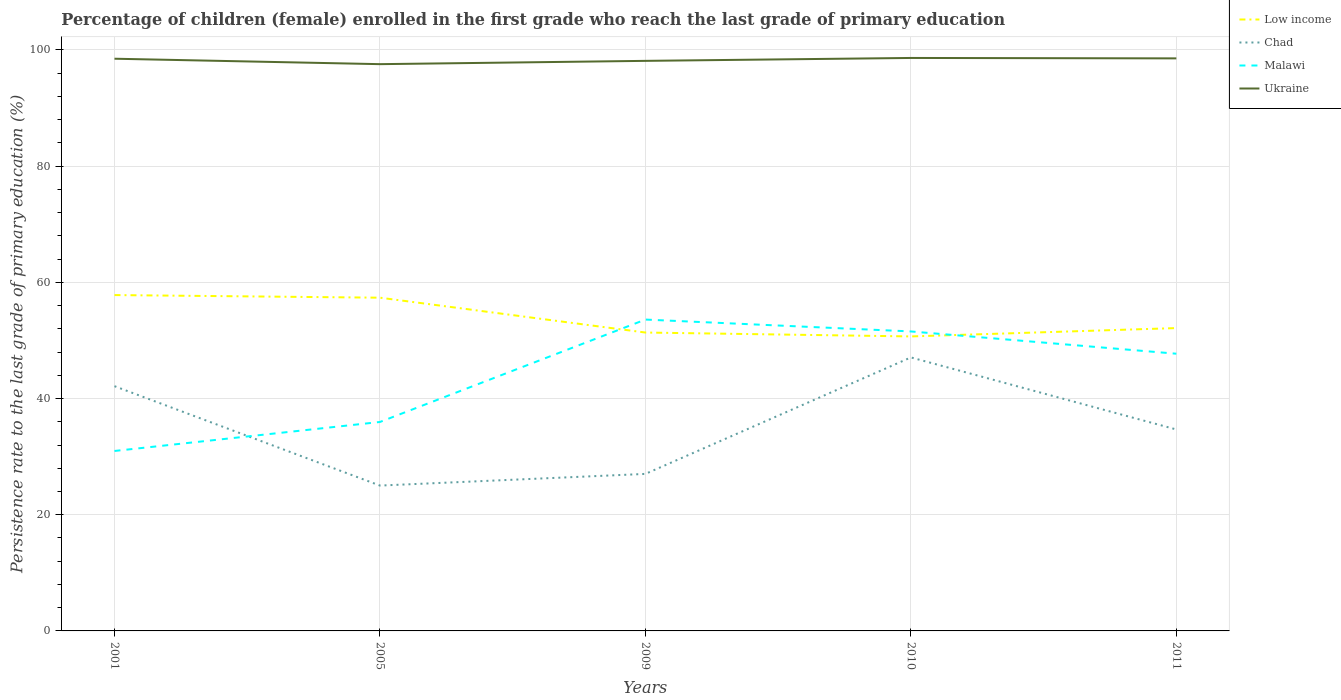Is the number of lines equal to the number of legend labels?
Ensure brevity in your answer.  Yes. Across all years, what is the maximum persistence rate of children in Ukraine?
Provide a short and direct response. 97.56. In which year was the persistence rate of children in Chad maximum?
Provide a short and direct response. 2005. What is the total persistence rate of children in Ukraine in the graph?
Offer a very short reply. -0.43. What is the difference between the highest and the second highest persistence rate of children in Ukraine?
Provide a succinct answer. 1.07. Is the persistence rate of children in Low income strictly greater than the persistence rate of children in Ukraine over the years?
Make the answer very short. Yes. How many lines are there?
Your response must be concise. 4. What is the difference between two consecutive major ticks on the Y-axis?
Provide a short and direct response. 20. Are the values on the major ticks of Y-axis written in scientific E-notation?
Your response must be concise. No. Does the graph contain any zero values?
Make the answer very short. No. Does the graph contain grids?
Your response must be concise. Yes. Where does the legend appear in the graph?
Your response must be concise. Top right. How many legend labels are there?
Offer a very short reply. 4. What is the title of the graph?
Your answer should be compact. Percentage of children (female) enrolled in the first grade who reach the last grade of primary education. What is the label or title of the Y-axis?
Your response must be concise. Persistence rate to the last grade of primary education (%). What is the Persistence rate to the last grade of primary education (%) in Low income in 2001?
Keep it short and to the point. 57.81. What is the Persistence rate to the last grade of primary education (%) in Chad in 2001?
Offer a terse response. 42.13. What is the Persistence rate to the last grade of primary education (%) in Malawi in 2001?
Your answer should be compact. 30.97. What is the Persistence rate to the last grade of primary education (%) in Ukraine in 2001?
Give a very brief answer. 98.49. What is the Persistence rate to the last grade of primary education (%) of Low income in 2005?
Offer a terse response. 57.36. What is the Persistence rate to the last grade of primary education (%) in Chad in 2005?
Provide a succinct answer. 25.02. What is the Persistence rate to the last grade of primary education (%) of Malawi in 2005?
Provide a succinct answer. 35.97. What is the Persistence rate to the last grade of primary education (%) of Ukraine in 2005?
Provide a short and direct response. 97.56. What is the Persistence rate to the last grade of primary education (%) in Low income in 2009?
Keep it short and to the point. 51.36. What is the Persistence rate to the last grade of primary education (%) in Chad in 2009?
Offer a very short reply. 27.03. What is the Persistence rate to the last grade of primary education (%) of Malawi in 2009?
Offer a terse response. 53.59. What is the Persistence rate to the last grade of primary education (%) in Ukraine in 2009?
Provide a succinct answer. 98.13. What is the Persistence rate to the last grade of primary education (%) in Low income in 2010?
Ensure brevity in your answer.  50.69. What is the Persistence rate to the last grade of primary education (%) of Chad in 2010?
Your response must be concise. 47.08. What is the Persistence rate to the last grade of primary education (%) of Malawi in 2010?
Offer a very short reply. 51.55. What is the Persistence rate to the last grade of primary education (%) of Ukraine in 2010?
Provide a short and direct response. 98.63. What is the Persistence rate to the last grade of primary education (%) in Low income in 2011?
Provide a short and direct response. 52.13. What is the Persistence rate to the last grade of primary education (%) of Chad in 2011?
Offer a very short reply. 34.68. What is the Persistence rate to the last grade of primary education (%) of Malawi in 2011?
Your answer should be compact. 47.72. What is the Persistence rate to the last grade of primary education (%) in Ukraine in 2011?
Your answer should be compact. 98.55. Across all years, what is the maximum Persistence rate to the last grade of primary education (%) in Low income?
Your response must be concise. 57.81. Across all years, what is the maximum Persistence rate to the last grade of primary education (%) in Chad?
Keep it short and to the point. 47.08. Across all years, what is the maximum Persistence rate to the last grade of primary education (%) of Malawi?
Offer a terse response. 53.59. Across all years, what is the maximum Persistence rate to the last grade of primary education (%) of Ukraine?
Make the answer very short. 98.63. Across all years, what is the minimum Persistence rate to the last grade of primary education (%) in Low income?
Your answer should be compact. 50.69. Across all years, what is the minimum Persistence rate to the last grade of primary education (%) of Chad?
Provide a succinct answer. 25.02. Across all years, what is the minimum Persistence rate to the last grade of primary education (%) of Malawi?
Provide a succinct answer. 30.97. Across all years, what is the minimum Persistence rate to the last grade of primary education (%) in Ukraine?
Provide a short and direct response. 97.56. What is the total Persistence rate to the last grade of primary education (%) in Low income in the graph?
Your response must be concise. 269.35. What is the total Persistence rate to the last grade of primary education (%) of Chad in the graph?
Your response must be concise. 175.93. What is the total Persistence rate to the last grade of primary education (%) in Malawi in the graph?
Provide a succinct answer. 219.8. What is the total Persistence rate to the last grade of primary education (%) of Ukraine in the graph?
Offer a very short reply. 491.36. What is the difference between the Persistence rate to the last grade of primary education (%) of Low income in 2001 and that in 2005?
Ensure brevity in your answer.  0.45. What is the difference between the Persistence rate to the last grade of primary education (%) of Chad in 2001 and that in 2005?
Ensure brevity in your answer.  17.11. What is the difference between the Persistence rate to the last grade of primary education (%) of Malawi in 2001 and that in 2005?
Offer a very short reply. -4.99. What is the difference between the Persistence rate to the last grade of primary education (%) of Ukraine in 2001 and that in 2005?
Offer a very short reply. 0.94. What is the difference between the Persistence rate to the last grade of primary education (%) of Low income in 2001 and that in 2009?
Provide a succinct answer. 6.45. What is the difference between the Persistence rate to the last grade of primary education (%) in Chad in 2001 and that in 2009?
Provide a short and direct response. 15.1. What is the difference between the Persistence rate to the last grade of primary education (%) of Malawi in 2001 and that in 2009?
Your answer should be very brief. -22.62. What is the difference between the Persistence rate to the last grade of primary education (%) of Ukraine in 2001 and that in 2009?
Provide a short and direct response. 0.37. What is the difference between the Persistence rate to the last grade of primary education (%) of Low income in 2001 and that in 2010?
Provide a short and direct response. 7.12. What is the difference between the Persistence rate to the last grade of primary education (%) of Chad in 2001 and that in 2010?
Your answer should be compact. -4.95. What is the difference between the Persistence rate to the last grade of primary education (%) in Malawi in 2001 and that in 2010?
Keep it short and to the point. -20.58. What is the difference between the Persistence rate to the last grade of primary education (%) of Ukraine in 2001 and that in 2010?
Provide a succinct answer. -0.13. What is the difference between the Persistence rate to the last grade of primary education (%) of Low income in 2001 and that in 2011?
Your answer should be compact. 5.68. What is the difference between the Persistence rate to the last grade of primary education (%) of Chad in 2001 and that in 2011?
Offer a very short reply. 7.45. What is the difference between the Persistence rate to the last grade of primary education (%) in Malawi in 2001 and that in 2011?
Your response must be concise. -16.74. What is the difference between the Persistence rate to the last grade of primary education (%) in Ukraine in 2001 and that in 2011?
Keep it short and to the point. -0.06. What is the difference between the Persistence rate to the last grade of primary education (%) in Low income in 2005 and that in 2009?
Provide a succinct answer. 6. What is the difference between the Persistence rate to the last grade of primary education (%) in Chad in 2005 and that in 2009?
Make the answer very short. -2.01. What is the difference between the Persistence rate to the last grade of primary education (%) in Malawi in 2005 and that in 2009?
Provide a short and direct response. -17.63. What is the difference between the Persistence rate to the last grade of primary education (%) in Ukraine in 2005 and that in 2009?
Your response must be concise. -0.57. What is the difference between the Persistence rate to the last grade of primary education (%) in Low income in 2005 and that in 2010?
Offer a very short reply. 6.67. What is the difference between the Persistence rate to the last grade of primary education (%) in Chad in 2005 and that in 2010?
Offer a terse response. -22.06. What is the difference between the Persistence rate to the last grade of primary education (%) in Malawi in 2005 and that in 2010?
Make the answer very short. -15.58. What is the difference between the Persistence rate to the last grade of primary education (%) of Ukraine in 2005 and that in 2010?
Your answer should be very brief. -1.07. What is the difference between the Persistence rate to the last grade of primary education (%) in Low income in 2005 and that in 2011?
Your answer should be compact. 5.23. What is the difference between the Persistence rate to the last grade of primary education (%) of Chad in 2005 and that in 2011?
Provide a short and direct response. -9.66. What is the difference between the Persistence rate to the last grade of primary education (%) in Malawi in 2005 and that in 2011?
Your response must be concise. -11.75. What is the difference between the Persistence rate to the last grade of primary education (%) in Ukraine in 2005 and that in 2011?
Give a very brief answer. -0.99. What is the difference between the Persistence rate to the last grade of primary education (%) of Low income in 2009 and that in 2010?
Make the answer very short. 0.67. What is the difference between the Persistence rate to the last grade of primary education (%) in Chad in 2009 and that in 2010?
Your response must be concise. -20.05. What is the difference between the Persistence rate to the last grade of primary education (%) in Malawi in 2009 and that in 2010?
Provide a short and direct response. 2.04. What is the difference between the Persistence rate to the last grade of primary education (%) of Ukraine in 2009 and that in 2010?
Offer a terse response. -0.5. What is the difference between the Persistence rate to the last grade of primary education (%) of Low income in 2009 and that in 2011?
Provide a short and direct response. -0.77. What is the difference between the Persistence rate to the last grade of primary education (%) in Chad in 2009 and that in 2011?
Your answer should be compact. -7.65. What is the difference between the Persistence rate to the last grade of primary education (%) in Malawi in 2009 and that in 2011?
Give a very brief answer. 5.88. What is the difference between the Persistence rate to the last grade of primary education (%) in Ukraine in 2009 and that in 2011?
Provide a succinct answer. -0.43. What is the difference between the Persistence rate to the last grade of primary education (%) of Low income in 2010 and that in 2011?
Provide a short and direct response. -1.44. What is the difference between the Persistence rate to the last grade of primary education (%) in Chad in 2010 and that in 2011?
Make the answer very short. 12.4. What is the difference between the Persistence rate to the last grade of primary education (%) of Malawi in 2010 and that in 2011?
Provide a short and direct response. 3.83. What is the difference between the Persistence rate to the last grade of primary education (%) in Ukraine in 2010 and that in 2011?
Your answer should be very brief. 0.07. What is the difference between the Persistence rate to the last grade of primary education (%) in Low income in 2001 and the Persistence rate to the last grade of primary education (%) in Chad in 2005?
Provide a succinct answer. 32.79. What is the difference between the Persistence rate to the last grade of primary education (%) of Low income in 2001 and the Persistence rate to the last grade of primary education (%) of Malawi in 2005?
Your answer should be compact. 21.84. What is the difference between the Persistence rate to the last grade of primary education (%) in Low income in 2001 and the Persistence rate to the last grade of primary education (%) in Ukraine in 2005?
Ensure brevity in your answer.  -39.75. What is the difference between the Persistence rate to the last grade of primary education (%) of Chad in 2001 and the Persistence rate to the last grade of primary education (%) of Malawi in 2005?
Provide a short and direct response. 6.16. What is the difference between the Persistence rate to the last grade of primary education (%) in Chad in 2001 and the Persistence rate to the last grade of primary education (%) in Ukraine in 2005?
Your answer should be compact. -55.43. What is the difference between the Persistence rate to the last grade of primary education (%) of Malawi in 2001 and the Persistence rate to the last grade of primary education (%) of Ukraine in 2005?
Offer a very short reply. -66.58. What is the difference between the Persistence rate to the last grade of primary education (%) of Low income in 2001 and the Persistence rate to the last grade of primary education (%) of Chad in 2009?
Your answer should be compact. 30.78. What is the difference between the Persistence rate to the last grade of primary education (%) in Low income in 2001 and the Persistence rate to the last grade of primary education (%) in Malawi in 2009?
Give a very brief answer. 4.22. What is the difference between the Persistence rate to the last grade of primary education (%) in Low income in 2001 and the Persistence rate to the last grade of primary education (%) in Ukraine in 2009?
Your answer should be compact. -40.32. What is the difference between the Persistence rate to the last grade of primary education (%) of Chad in 2001 and the Persistence rate to the last grade of primary education (%) of Malawi in 2009?
Keep it short and to the point. -11.47. What is the difference between the Persistence rate to the last grade of primary education (%) in Chad in 2001 and the Persistence rate to the last grade of primary education (%) in Ukraine in 2009?
Provide a short and direct response. -56. What is the difference between the Persistence rate to the last grade of primary education (%) of Malawi in 2001 and the Persistence rate to the last grade of primary education (%) of Ukraine in 2009?
Provide a succinct answer. -67.15. What is the difference between the Persistence rate to the last grade of primary education (%) of Low income in 2001 and the Persistence rate to the last grade of primary education (%) of Chad in 2010?
Provide a succinct answer. 10.73. What is the difference between the Persistence rate to the last grade of primary education (%) of Low income in 2001 and the Persistence rate to the last grade of primary education (%) of Malawi in 2010?
Make the answer very short. 6.26. What is the difference between the Persistence rate to the last grade of primary education (%) in Low income in 2001 and the Persistence rate to the last grade of primary education (%) in Ukraine in 2010?
Your response must be concise. -40.81. What is the difference between the Persistence rate to the last grade of primary education (%) of Chad in 2001 and the Persistence rate to the last grade of primary education (%) of Malawi in 2010?
Your answer should be compact. -9.42. What is the difference between the Persistence rate to the last grade of primary education (%) of Chad in 2001 and the Persistence rate to the last grade of primary education (%) of Ukraine in 2010?
Offer a terse response. -56.5. What is the difference between the Persistence rate to the last grade of primary education (%) in Malawi in 2001 and the Persistence rate to the last grade of primary education (%) in Ukraine in 2010?
Offer a very short reply. -67.65. What is the difference between the Persistence rate to the last grade of primary education (%) of Low income in 2001 and the Persistence rate to the last grade of primary education (%) of Chad in 2011?
Your answer should be compact. 23.13. What is the difference between the Persistence rate to the last grade of primary education (%) of Low income in 2001 and the Persistence rate to the last grade of primary education (%) of Malawi in 2011?
Offer a very short reply. 10.09. What is the difference between the Persistence rate to the last grade of primary education (%) in Low income in 2001 and the Persistence rate to the last grade of primary education (%) in Ukraine in 2011?
Offer a terse response. -40.74. What is the difference between the Persistence rate to the last grade of primary education (%) in Chad in 2001 and the Persistence rate to the last grade of primary education (%) in Malawi in 2011?
Keep it short and to the point. -5.59. What is the difference between the Persistence rate to the last grade of primary education (%) of Chad in 2001 and the Persistence rate to the last grade of primary education (%) of Ukraine in 2011?
Give a very brief answer. -56.42. What is the difference between the Persistence rate to the last grade of primary education (%) of Malawi in 2001 and the Persistence rate to the last grade of primary education (%) of Ukraine in 2011?
Your response must be concise. -67.58. What is the difference between the Persistence rate to the last grade of primary education (%) of Low income in 2005 and the Persistence rate to the last grade of primary education (%) of Chad in 2009?
Your answer should be very brief. 30.33. What is the difference between the Persistence rate to the last grade of primary education (%) of Low income in 2005 and the Persistence rate to the last grade of primary education (%) of Malawi in 2009?
Your response must be concise. 3.77. What is the difference between the Persistence rate to the last grade of primary education (%) in Low income in 2005 and the Persistence rate to the last grade of primary education (%) in Ukraine in 2009?
Make the answer very short. -40.77. What is the difference between the Persistence rate to the last grade of primary education (%) of Chad in 2005 and the Persistence rate to the last grade of primary education (%) of Malawi in 2009?
Ensure brevity in your answer.  -28.57. What is the difference between the Persistence rate to the last grade of primary education (%) of Chad in 2005 and the Persistence rate to the last grade of primary education (%) of Ukraine in 2009?
Your response must be concise. -73.11. What is the difference between the Persistence rate to the last grade of primary education (%) in Malawi in 2005 and the Persistence rate to the last grade of primary education (%) in Ukraine in 2009?
Keep it short and to the point. -62.16. What is the difference between the Persistence rate to the last grade of primary education (%) of Low income in 2005 and the Persistence rate to the last grade of primary education (%) of Chad in 2010?
Provide a succinct answer. 10.28. What is the difference between the Persistence rate to the last grade of primary education (%) of Low income in 2005 and the Persistence rate to the last grade of primary education (%) of Malawi in 2010?
Provide a short and direct response. 5.81. What is the difference between the Persistence rate to the last grade of primary education (%) of Low income in 2005 and the Persistence rate to the last grade of primary education (%) of Ukraine in 2010?
Give a very brief answer. -41.27. What is the difference between the Persistence rate to the last grade of primary education (%) in Chad in 2005 and the Persistence rate to the last grade of primary education (%) in Malawi in 2010?
Provide a short and direct response. -26.53. What is the difference between the Persistence rate to the last grade of primary education (%) of Chad in 2005 and the Persistence rate to the last grade of primary education (%) of Ukraine in 2010?
Give a very brief answer. -73.61. What is the difference between the Persistence rate to the last grade of primary education (%) of Malawi in 2005 and the Persistence rate to the last grade of primary education (%) of Ukraine in 2010?
Provide a short and direct response. -62.66. What is the difference between the Persistence rate to the last grade of primary education (%) in Low income in 2005 and the Persistence rate to the last grade of primary education (%) in Chad in 2011?
Your answer should be compact. 22.68. What is the difference between the Persistence rate to the last grade of primary education (%) of Low income in 2005 and the Persistence rate to the last grade of primary education (%) of Malawi in 2011?
Your answer should be very brief. 9.64. What is the difference between the Persistence rate to the last grade of primary education (%) in Low income in 2005 and the Persistence rate to the last grade of primary education (%) in Ukraine in 2011?
Your answer should be very brief. -41.19. What is the difference between the Persistence rate to the last grade of primary education (%) in Chad in 2005 and the Persistence rate to the last grade of primary education (%) in Malawi in 2011?
Your answer should be very brief. -22.7. What is the difference between the Persistence rate to the last grade of primary education (%) in Chad in 2005 and the Persistence rate to the last grade of primary education (%) in Ukraine in 2011?
Provide a short and direct response. -73.53. What is the difference between the Persistence rate to the last grade of primary education (%) in Malawi in 2005 and the Persistence rate to the last grade of primary education (%) in Ukraine in 2011?
Ensure brevity in your answer.  -62.58. What is the difference between the Persistence rate to the last grade of primary education (%) of Low income in 2009 and the Persistence rate to the last grade of primary education (%) of Chad in 2010?
Your answer should be very brief. 4.28. What is the difference between the Persistence rate to the last grade of primary education (%) of Low income in 2009 and the Persistence rate to the last grade of primary education (%) of Malawi in 2010?
Give a very brief answer. -0.19. What is the difference between the Persistence rate to the last grade of primary education (%) of Low income in 2009 and the Persistence rate to the last grade of primary education (%) of Ukraine in 2010?
Offer a very short reply. -47.26. What is the difference between the Persistence rate to the last grade of primary education (%) in Chad in 2009 and the Persistence rate to the last grade of primary education (%) in Malawi in 2010?
Provide a succinct answer. -24.52. What is the difference between the Persistence rate to the last grade of primary education (%) of Chad in 2009 and the Persistence rate to the last grade of primary education (%) of Ukraine in 2010?
Make the answer very short. -71.6. What is the difference between the Persistence rate to the last grade of primary education (%) in Malawi in 2009 and the Persistence rate to the last grade of primary education (%) in Ukraine in 2010?
Your answer should be compact. -45.03. What is the difference between the Persistence rate to the last grade of primary education (%) in Low income in 2009 and the Persistence rate to the last grade of primary education (%) in Chad in 2011?
Offer a terse response. 16.68. What is the difference between the Persistence rate to the last grade of primary education (%) in Low income in 2009 and the Persistence rate to the last grade of primary education (%) in Malawi in 2011?
Ensure brevity in your answer.  3.65. What is the difference between the Persistence rate to the last grade of primary education (%) in Low income in 2009 and the Persistence rate to the last grade of primary education (%) in Ukraine in 2011?
Your answer should be very brief. -47.19. What is the difference between the Persistence rate to the last grade of primary education (%) in Chad in 2009 and the Persistence rate to the last grade of primary education (%) in Malawi in 2011?
Your response must be concise. -20.69. What is the difference between the Persistence rate to the last grade of primary education (%) of Chad in 2009 and the Persistence rate to the last grade of primary education (%) of Ukraine in 2011?
Your answer should be compact. -71.52. What is the difference between the Persistence rate to the last grade of primary education (%) of Malawi in 2009 and the Persistence rate to the last grade of primary education (%) of Ukraine in 2011?
Give a very brief answer. -44.96. What is the difference between the Persistence rate to the last grade of primary education (%) in Low income in 2010 and the Persistence rate to the last grade of primary education (%) in Chad in 2011?
Your response must be concise. 16.01. What is the difference between the Persistence rate to the last grade of primary education (%) of Low income in 2010 and the Persistence rate to the last grade of primary education (%) of Malawi in 2011?
Your answer should be very brief. 2.98. What is the difference between the Persistence rate to the last grade of primary education (%) in Low income in 2010 and the Persistence rate to the last grade of primary education (%) in Ukraine in 2011?
Keep it short and to the point. -47.86. What is the difference between the Persistence rate to the last grade of primary education (%) of Chad in 2010 and the Persistence rate to the last grade of primary education (%) of Malawi in 2011?
Your answer should be compact. -0.64. What is the difference between the Persistence rate to the last grade of primary education (%) in Chad in 2010 and the Persistence rate to the last grade of primary education (%) in Ukraine in 2011?
Provide a succinct answer. -51.47. What is the difference between the Persistence rate to the last grade of primary education (%) in Malawi in 2010 and the Persistence rate to the last grade of primary education (%) in Ukraine in 2011?
Make the answer very short. -47. What is the average Persistence rate to the last grade of primary education (%) in Low income per year?
Offer a terse response. 53.87. What is the average Persistence rate to the last grade of primary education (%) in Chad per year?
Your response must be concise. 35.19. What is the average Persistence rate to the last grade of primary education (%) of Malawi per year?
Your answer should be compact. 43.96. What is the average Persistence rate to the last grade of primary education (%) in Ukraine per year?
Offer a terse response. 98.27. In the year 2001, what is the difference between the Persistence rate to the last grade of primary education (%) in Low income and Persistence rate to the last grade of primary education (%) in Chad?
Keep it short and to the point. 15.68. In the year 2001, what is the difference between the Persistence rate to the last grade of primary education (%) of Low income and Persistence rate to the last grade of primary education (%) of Malawi?
Provide a succinct answer. 26.84. In the year 2001, what is the difference between the Persistence rate to the last grade of primary education (%) of Low income and Persistence rate to the last grade of primary education (%) of Ukraine?
Provide a short and direct response. -40.68. In the year 2001, what is the difference between the Persistence rate to the last grade of primary education (%) in Chad and Persistence rate to the last grade of primary education (%) in Malawi?
Your response must be concise. 11.15. In the year 2001, what is the difference between the Persistence rate to the last grade of primary education (%) in Chad and Persistence rate to the last grade of primary education (%) in Ukraine?
Offer a terse response. -56.37. In the year 2001, what is the difference between the Persistence rate to the last grade of primary education (%) of Malawi and Persistence rate to the last grade of primary education (%) of Ukraine?
Your response must be concise. -67.52. In the year 2005, what is the difference between the Persistence rate to the last grade of primary education (%) of Low income and Persistence rate to the last grade of primary education (%) of Chad?
Make the answer very short. 32.34. In the year 2005, what is the difference between the Persistence rate to the last grade of primary education (%) in Low income and Persistence rate to the last grade of primary education (%) in Malawi?
Make the answer very short. 21.39. In the year 2005, what is the difference between the Persistence rate to the last grade of primary education (%) in Low income and Persistence rate to the last grade of primary education (%) in Ukraine?
Your response must be concise. -40.2. In the year 2005, what is the difference between the Persistence rate to the last grade of primary education (%) of Chad and Persistence rate to the last grade of primary education (%) of Malawi?
Keep it short and to the point. -10.95. In the year 2005, what is the difference between the Persistence rate to the last grade of primary education (%) in Chad and Persistence rate to the last grade of primary education (%) in Ukraine?
Keep it short and to the point. -72.54. In the year 2005, what is the difference between the Persistence rate to the last grade of primary education (%) of Malawi and Persistence rate to the last grade of primary education (%) of Ukraine?
Your answer should be compact. -61.59. In the year 2009, what is the difference between the Persistence rate to the last grade of primary education (%) in Low income and Persistence rate to the last grade of primary education (%) in Chad?
Offer a very short reply. 24.33. In the year 2009, what is the difference between the Persistence rate to the last grade of primary education (%) of Low income and Persistence rate to the last grade of primary education (%) of Malawi?
Provide a short and direct response. -2.23. In the year 2009, what is the difference between the Persistence rate to the last grade of primary education (%) in Low income and Persistence rate to the last grade of primary education (%) in Ukraine?
Ensure brevity in your answer.  -46.77. In the year 2009, what is the difference between the Persistence rate to the last grade of primary education (%) in Chad and Persistence rate to the last grade of primary education (%) in Malawi?
Your response must be concise. -26.57. In the year 2009, what is the difference between the Persistence rate to the last grade of primary education (%) of Chad and Persistence rate to the last grade of primary education (%) of Ukraine?
Your answer should be very brief. -71.1. In the year 2009, what is the difference between the Persistence rate to the last grade of primary education (%) of Malawi and Persistence rate to the last grade of primary education (%) of Ukraine?
Ensure brevity in your answer.  -44.53. In the year 2010, what is the difference between the Persistence rate to the last grade of primary education (%) of Low income and Persistence rate to the last grade of primary education (%) of Chad?
Provide a succinct answer. 3.61. In the year 2010, what is the difference between the Persistence rate to the last grade of primary education (%) in Low income and Persistence rate to the last grade of primary education (%) in Malawi?
Give a very brief answer. -0.86. In the year 2010, what is the difference between the Persistence rate to the last grade of primary education (%) in Low income and Persistence rate to the last grade of primary education (%) in Ukraine?
Offer a very short reply. -47.93. In the year 2010, what is the difference between the Persistence rate to the last grade of primary education (%) in Chad and Persistence rate to the last grade of primary education (%) in Malawi?
Offer a terse response. -4.47. In the year 2010, what is the difference between the Persistence rate to the last grade of primary education (%) of Chad and Persistence rate to the last grade of primary education (%) of Ukraine?
Offer a terse response. -51.55. In the year 2010, what is the difference between the Persistence rate to the last grade of primary education (%) in Malawi and Persistence rate to the last grade of primary education (%) in Ukraine?
Provide a short and direct response. -47.08. In the year 2011, what is the difference between the Persistence rate to the last grade of primary education (%) in Low income and Persistence rate to the last grade of primary education (%) in Chad?
Give a very brief answer. 17.45. In the year 2011, what is the difference between the Persistence rate to the last grade of primary education (%) in Low income and Persistence rate to the last grade of primary education (%) in Malawi?
Offer a very short reply. 4.41. In the year 2011, what is the difference between the Persistence rate to the last grade of primary education (%) in Low income and Persistence rate to the last grade of primary education (%) in Ukraine?
Give a very brief answer. -46.42. In the year 2011, what is the difference between the Persistence rate to the last grade of primary education (%) in Chad and Persistence rate to the last grade of primary education (%) in Malawi?
Give a very brief answer. -13.04. In the year 2011, what is the difference between the Persistence rate to the last grade of primary education (%) in Chad and Persistence rate to the last grade of primary education (%) in Ukraine?
Provide a short and direct response. -63.88. In the year 2011, what is the difference between the Persistence rate to the last grade of primary education (%) of Malawi and Persistence rate to the last grade of primary education (%) of Ukraine?
Your answer should be compact. -50.84. What is the ratio of the Persistence rate to the last grade of primary education (%) of Low income in 2001 to that in 2005?
Your answer should be compact. 1.01. What is the ratio of the Persistence rate to the last grade of primary education (%) in Chad in 2001 to that in 2005?
Offer a terse response. 1.68. What is the ratio of the Persistence rate to the last grade of primary education (%) in Malawi in 2001 to that in 2005?
Provide a succinct answer. 0.86. What is the ratio of the Persistence rate to the last grade of primary education (%) in Ukraine in 2001 to that in 2005?
Provide a short and direct response. 1.01. What is the ratio of the Persistence rate to the last grade of primary education (%) in Low income in 2001 to that in 2009?
Provide a short and direct response. 1.13. What is the ratio of the Persistence rate to the last grade of primary education (%) in Chad in 2001 to that in 2009?
Ensure brevity in your answer.  1.56. What is the ratio of the Persistence rate to the last grade of primary education (%) of Malawi in 2001 to that in 2009?
Your response must be concise. 0.58. What is the ratio of the Persistence rate to the last grade of primary education (%) in Low income in 2001 to that in 2010?
Provide a succinct answer. 1.14. What is the ratio of the Persistence rate to the last grade of primary education (%) in Chad in 2001 to that in 2010?
Make the answer very short. 0.89. What is the ratio of the Persistence rate to the last grade of primary education (%) in Malawi in 2001 to that in 2010?
Make the answer very short. 0.6. What is the ratio of the Persistence rate to the last grade of primary education (%) of Ukraine in 2001 to that in 2010?
Provide a short and direct response. 1. What is the ratio of the Persistence rate to the last grade of primary education (%) of Low income in 2001 to that in 2011?
Make the answer very short. 1.11. What is the ratio of the Persistence rate to the last grade of primary education (%) in Chad in 2001 to that in 2011?
Keep it short and to the point. 1.21. What is the ratio of the Persistence rate to the last grade of primary education (%) in Malawi in 2001 to that in 2011?
Your response must be concise. 0.65. What is the ratio of the Persistence rate to the last grade of primary education (%) in Ukraine in 2001 to that in 2011?
Keep it short and to the point. 1. What is the ratio of the Persistence rate to the last grade of primary education (%) in Low income in 2005 to that in 2009?
Provide a succinct answer. 1.12. What is the ratio of the Persistence rate to the last grade of primary education (%) in Chad in 2005 to that in 2009?
Offer a very short reply. 0.93. What is the ratio of the Persistence rate to the last grade of primary education (%) in Malawi in 2005 to that in 2009?
Offer a terse response. 0.67. What is the ratio of the Persistence rate to the last grade of primary education (%) in Ukraine in 2005 to that in 2009?
Make the answer very short. 0.99. What is the ratio of the Persistence rate to the last grade of primary education (%) of Low income in 2005 to that in 2010?
Provide a succinct answer. 1.13. What is the ratio of the Persistence rate to the last grade of primary education (%) of Chad in 2005 to that in 2010?
Your answer should be compact. 0.53. What is the ratio of the Persistence rate to the last grade of primary education (%) in Malawi in 2005 to that in 2010?
Offer a terse response. 0.7. What is the ratio of the Persistence rate to the last grade of primary education (%) in Low income in 2005 to that in 2011?
Your response must be concise. 1.1. What is the ratio of the Persistence rate to the last grade of primary education (%) of Chad in 2005 to that in 2011?
Give a very brief answer. 0.72. What is the ratio of the Persistence rate to the last grade of primary education (%) of Malawi in 2005 to that in 2011?
Provide a succinct answer. 0.75. What is the ratio of the Persistence rate to the last grade of primary education (%) in Low income in 2009 to that in 2010?
Keep it short and to the point. 1.01. What is the ratio of the Persistence rate to the last grade of primary education (%) of Chad in 2009 to that in 2010?
Offer a terse response. 0.57. What is the ratio of the Persistence rate to the last grade of primary education (%) of Malawi in 2009 to that in 2010?
Make the answer very short. 1.04. What is the ratio of the Persistence rate to the last grade of primary education (%) in Chad in 2009 to that in 2011?
Keep it short and to the point. 0.78. What is the ratio of the Persistence rate to the last grade of primary education (%) in Malawi in 2009 to that in 2011?
Your response must be concise. 1.12. What is the ratio of the Persistence rate to the last grade of primary education (%) of Ukraine in 2009 to that in 2011?
Offer a very short reply. 1. What is the ratio of the Persistence rate to the last grade of primary education (%) in Low income in 2010 to that in 2011?
Make the answer very short. 0.97. What is the ratio of the Persistence rate to the last grade of primary education (%) in Chad in 2010 to that in 2011?
Give a very brief answer. 1.36. What is the ratio of the Persistence rate to the last grade of primary education (%) of Malawi in 2010 to that in 2011?
Provide a short and direct response. 1.08. What is the ratio of the Persistence rate to the last grade of primary education (%) of Ukraine in 2010 to that in 2011?
Your answer should be compact. 1. What is the difference between the highest and the second highest Persistence rate to the last grade of primary education (%) in Low income?
Keep it short and to the point. 0.45. What is the difference between the highest and the second highest Persistence rate to the last grade of primary education (%) of Chad?
Your response must be concise. 4.95. What is the difference between the highest and the second highest Persistence rate to the last grade of primary education (%) in Malawi?
Keep it short and to the point. 2.04. What is the difference between the highest and the second highest Persistence rate to the last grade of primary education (%) in Ukraine?
Your answer should be very brief. 0.07. What is the difference between the highest and the lowest Persistence rate to the last grade of primary education (%) of Low income?
Make the answer very short. 7.12. What is the difference between the highest and the lowest Persistence rate to the last grade of primary education (%) of Chad?
Offer a terse response. 22.06. What is the difference between the highest and the lowest Persistence rate to the last grade of primary education (%) of Malawi?
Make the answer very short. 22.62. What is the difference between the highest and the lowest Persistence rate to the last grade of primary education (%) in Ukraine?
Offer a terse response. 1.07. 